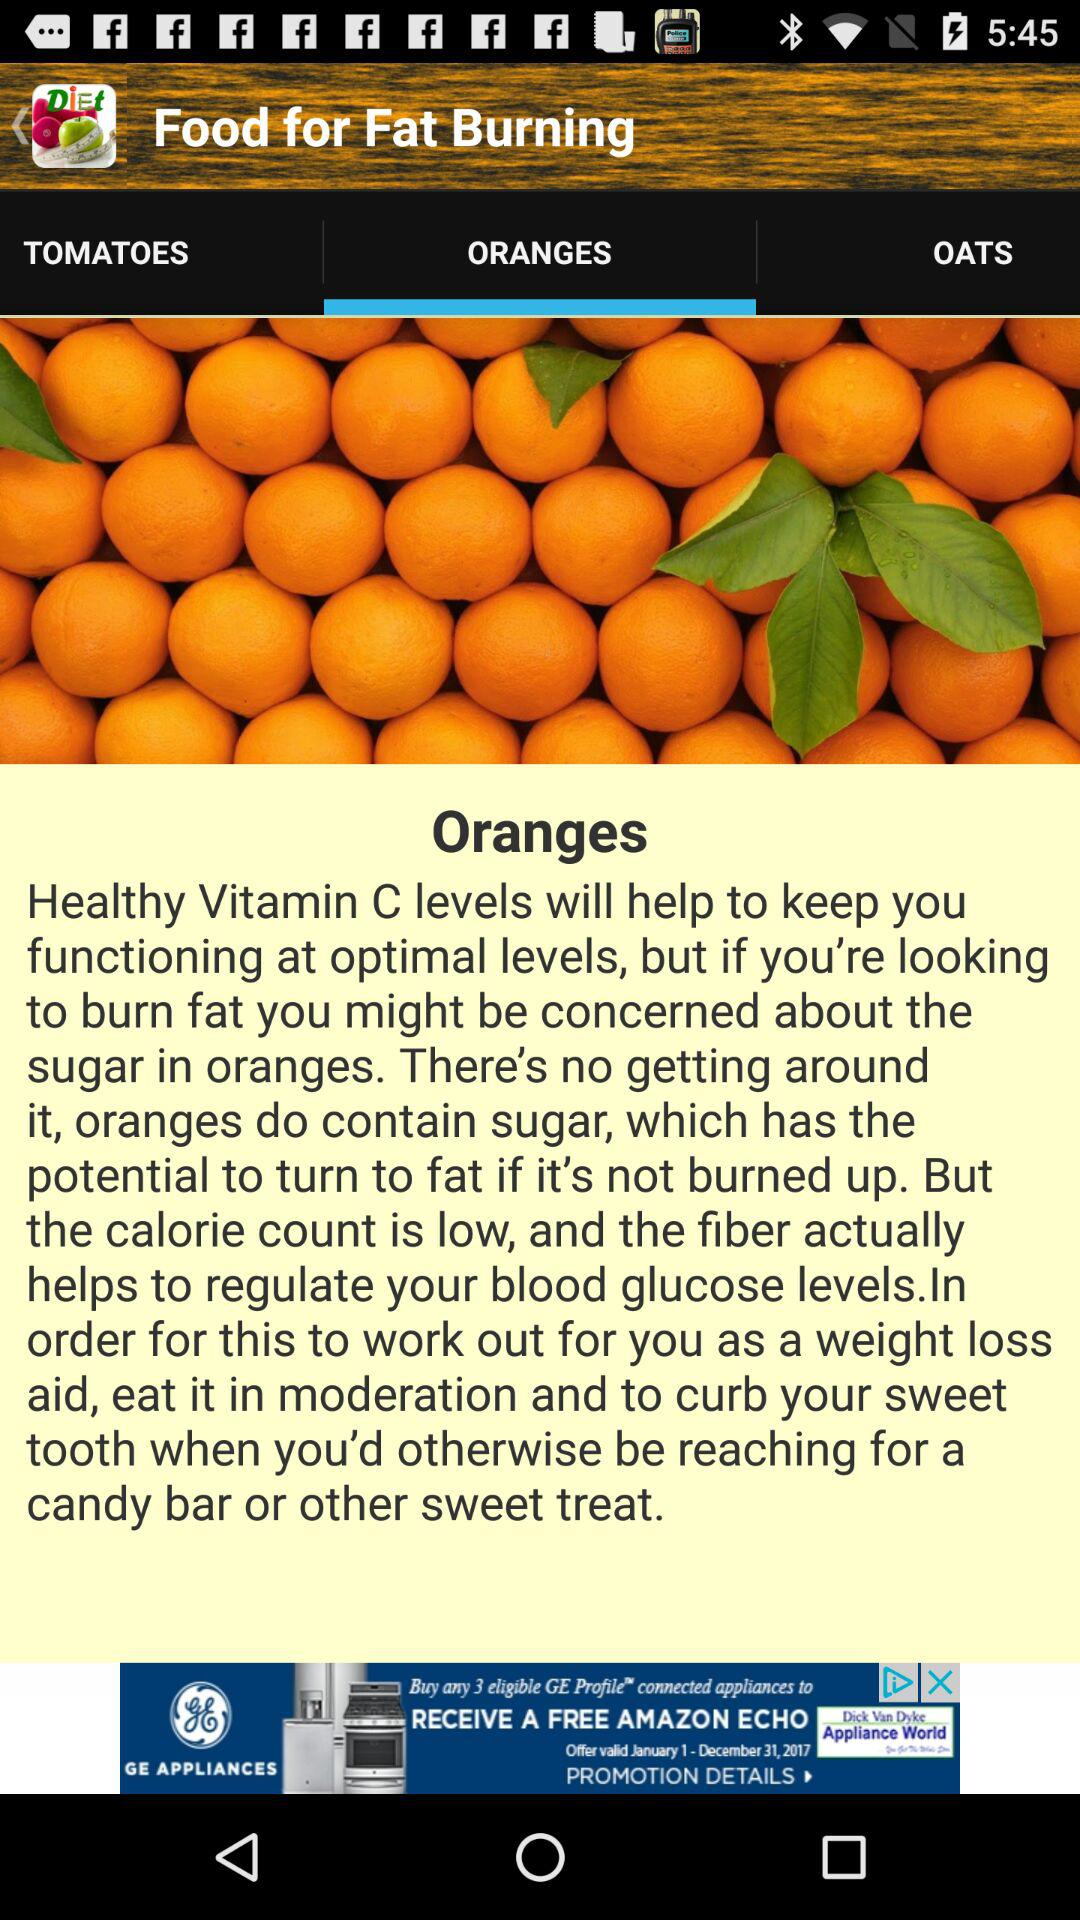Which food's information is provided? The food is oranges. 